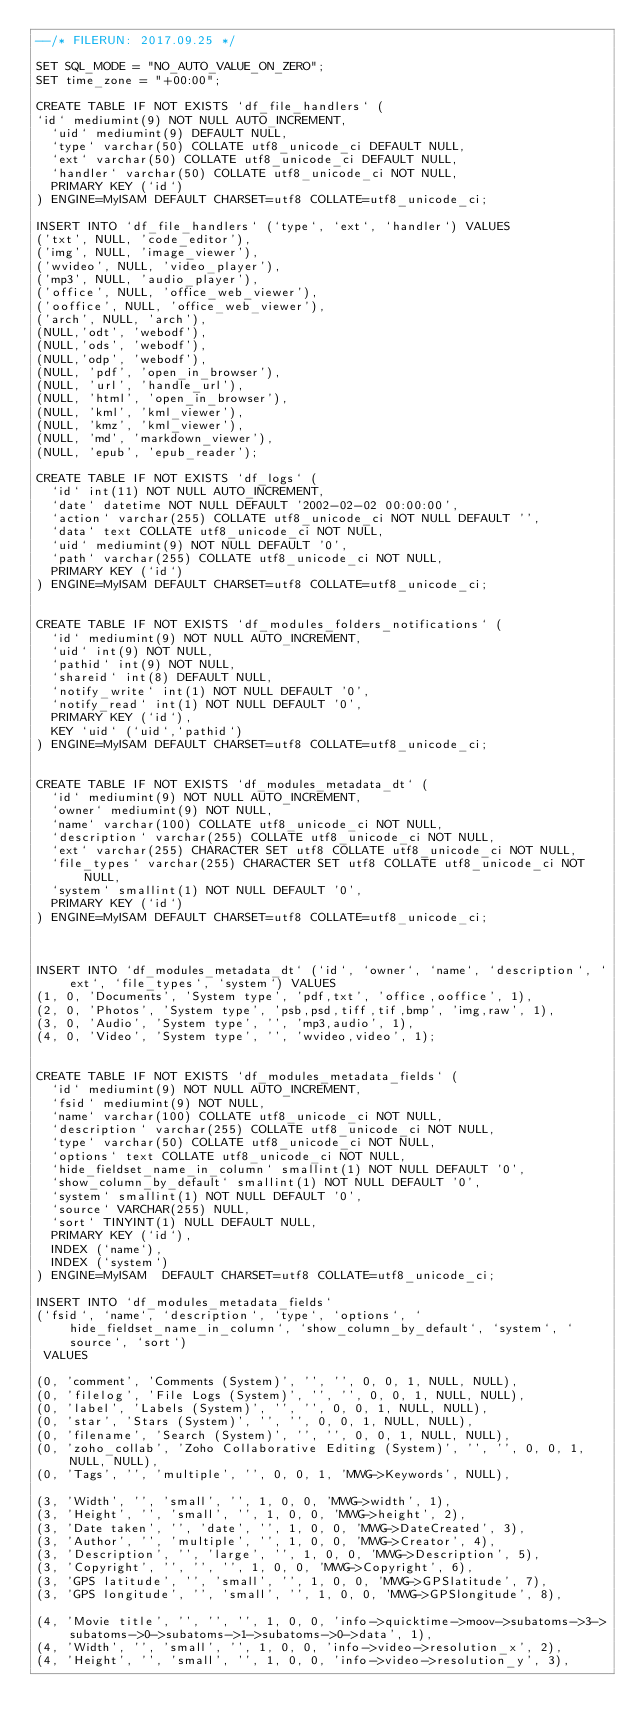<code> <loc_0><loc_0><loc_500><loc_500><_SQL_>--/* FILERUN: 2017.09.25 */

SET SQL_MODE = "NO_AUTO_VALUE_ON_ZERO";
SET time_zone = "+00:00";

CREATE TABLE IF NOT EXISTS `df_file_handlers` (
`id` mediumint(9) NOT NULL AUTO_INCREMENT,
  `uid` mediumint(9) DEFAULT NULL,
  `type` varchar(50) COLLATE utf8_unicode_ci DEFAULT NULL,
  `ext` varchar(50) COLLATE utf8_unicode_ci DEFAULT NULL,
  `handler` varchar(50) COLLATE utf8_unicode_ci NOT NULL,
  PRIMARY KEY (`id`)
) ENGINE=MyISAM DEFAULT CHARSET=utf8 COLLATE=utf8_unicode_ci;

INSERT INTO `df_file_handlers` (`type`, `ext`, `handler`) VALUES
('txt', NULL, 'code_editor'),
('img', NULL, 'image_viewer'),
('wvideo', NULL, 'video_player'),
('mp3', NULL, 'audio_player'),
('office', NULL, 'office_web_viewer'),
('ooffice', NULL, 'office_web_viewer'),
('arch', NULL, 'arch'),
(NULL,'odt', 'webodf'),
(NULL,'ods', 'webodf'),
(NULL,'odp', 'webodf'),
(NULL, 'pdf', 'open_in_browser'),
(NULL, 'url', 'handle_url'),
(NULL, 'html', 'open_in_browser'),
(NULL, 'kml', 'kml_viewer'),
(NULL, 'kmz', 'kml_viewer'),
(NULL, 'md', 'markdown_viewer'),
(NULL, 'epub', 'epub_reader');

CREATE TABLE IF NOT EXISTS `df_logs` (
  `id` int(11) NOT NULL AUTO_INCREMENT,
  `date` datetime NOT NULL DEFAULT '2002-02-02 00:00:00',
  `action` varchar(255) COLLATE utf8_unicode_ci NOT NULL DEFAULT '',
  `data` text COLLATE utf8_unicode_ci NOT NULL,
  `uid` mediumint(9) NOT NULL DEFAULT '0',
  `path` varchar(255) COLLATE utf8_unicode_ci NOT NULL,
  PRIMARY KEY (`id`)
) ENGINE=MyISAM DEFAULT CHARSET=utf8 COLLATE=utf8_unicode_ci;


CREATE TABLE IF NOT EXISTS `df_modules_folders_notifications` (
  `id` mediumint(9) NOT NULL AUTO_INCREMENT,
  `uid` int(9) NOT NULL,
  `pathid` int(9) NOT NULL,
  `shareid` int(8) DEFAULT NULL,
  `notify_write` int(1) NOT NULL DEFAULT '0',
  `notify_read` int(1) NOT NULL DEFAULT '0',
  PRIMARY KEY (`id`),
  KEY `uid` (`uid`,`pathid`)
) ENGINE=MyISAM DEFAULT CHARSET=utf8 COLLATE=utf8_unicode_ci;


CREATE TABLE IF NOT EXISTS `df_modules_metadata_dt` (
  `id` mediumint(9) NOT NULL AUTO_INCREMENT,
  `owner` mediumint(9) NOT NULL,
  `name` varchar(100) COLLATE utf8_unicode_ci NOT NULL,
  `description` varchar(255) COLLATE utf8_unicode_ci NOT NULL,
  `ext` varchar(255) CHARACTER SET utf8 COLLATE utf8_unicode_ci NOT NULL,
  `file_types` varchar(255) CHARACTER SET utf8 COLLATE utf8_unicode_ci NOT NULL,
  `system` smallint(1) NOT NULL DEFAULT '0',
  PRIMARY KEY (`id`)
) ENGINE=MyISAM DEFAULT CHARSET=utf8 COLLATE=utf8_unicode_ci;



INSERT INTO `df_modules_metadata_dt` (`id`, `owner`, `name`, `description`, `ext`, `file_types`, `system`) VALUES
(1, 0, 'Documents', 'System type', 'pdf,txt', 'office,ooffice', 1),
(2, 0, 'Photos', 'System type', 'psb,psd,tiff,tif,bmp', 'img,raw', 1),
(3, 0, 'Audio', 'System type', '', 'mp3,audio', 1),
(4, 0, 'Video', 'System type', '', 'wvideo,video', 1);


CREATE TABLE IF NOT EXISTS `df_modules_metadata_fields` (
  `id` mediumint(9) NOT NULL AUTO_INCREMENT,
  `fsid` mediumint(9) NOT NULL,
  `name` varchar(100) COLLATE utf8_unicode_ci NOT NULL,
  `description` varchar(255) COLLATE utf8_unicode_ci NOT NULL,
  `type` varchar(50) COLLATE utf8_unicode_ci NOT NULL,
  `options` text COLLATE utf8_unicode_ci NOT NULL,
  `hide_fieldset_name_in_column` smallint(1) NOT NULL DEFAULT '0',
  `show_column_by_default` smallint(1) NOT NULL DEFAULT '0',
  `system` smallint(1) NOT NULL DEFAULT '0',
  `source` VARCHAR(255) NULL,
  `sort` TINYINT(1) NULL DEFAULT NULL,
  PRIMARY KEY (`id`),
  INDEX (`name`),
  INDEX (`system`)
) ENGINE=MyISAM  DEFAULT CHARSET=utf8 COLLATE=utf8_unicode_ci;

INSERT INTO `df_modules_metadata_fields` 
(`fsid`, `name`, `description`, `type`, `options`, `hide_fieldset_name_in_column`, `show_column_by_default`, `system`, `source`, `sort`)
 VALUES
 
(0, 'comment', 'Comments (System)', '', '', 0, 0, 1, NULL, NULL),
(0, 'filelog', 'File Logs (System)', '', '', 0, 0, 1, NULL, NULL),
(0, 'label', 'Labels (System)', '', '', 0, 0, 1, NULL, NULL),
(0, 'star', 'Stars (System)', '', '', 0, 0, 1, NULL, NULL),
(0, 'filename', 'Search (System)', '', '', 0, 0, 1, NULL, NULL),
(0, 'zoho_collab', 'Zoho Collaborative Editing (System)', '', '', 0, 0, 1, NULL, NULL),
(0, 'Tags', '', 'multiple', '', 0, 0, 1, 'MWG->Keywords', NULL),

(3, 'Width', '', 'small', '', 1, 0, 0, 'MWG->width', 1),
(3, 'Height', '', 'small', '', 1, 0, 0, 'MWG->height', 2),
(3, 'Date taken', '', 'date', '', 1, 0, 0, 'MWG->DateCreated', 3),
(3, 'Author', '', 'multiple', '', 1, 0, 0, 'MWG->Creator', 4),
(3, 'Description', '', 'large', '', 1, 0, 0, 'MWG->Description', 5),
(3, 'Copyright', '', '', '', 1, 0, 0, 'MWG->Copyright', 6),
(3, 'GPS latitude', '', 'small', '', 1, 0, 0, 'MWG->GPSlatitude', 7),
(3, 'GPS longitude', '', 'small', '', 1, 0, 0, 'MWG->GPSlongitude', 8),

(4, 'Movie title', '', '', '', 1, 0, 0, 'info->quicktime->moov->subatoms->3->subatoms->0->subatoms->1->subatoms->0->data', 1),
(4, 'Width', '', 'small', '', 1, 0, 0, 'info->video->resolution_x', 2),
(4, 'Height', '', 'small', '', 1, 0, 0, 'info->video->resolution_y', 3),</code> 